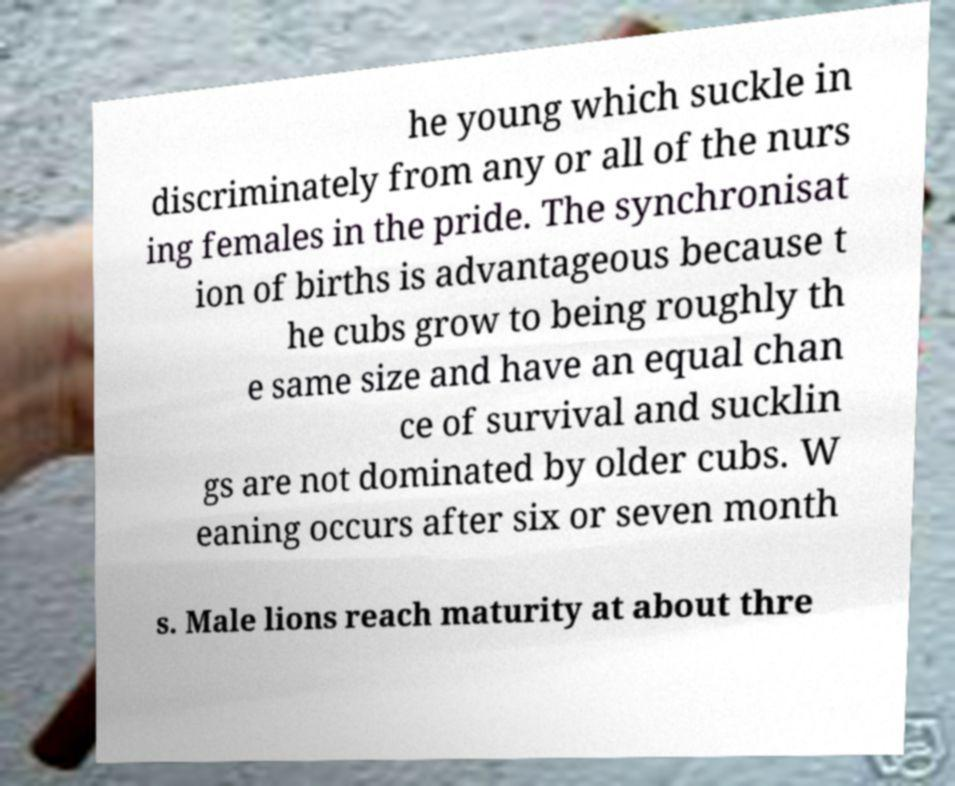There's text embedded in this image that I need extracted. Can you transcribe it verbatim? he young which suckle in discriminately from any or all of the nurs ing females in the pride. The synchronisat ion of births is advantageous because t he cubs grow to being roughly th e same size and have an equal chan ce of survival and sucklin gs are not dominated by older cubs. W eaning occurs after six or seven month s. Male lions reach maturity at about thre 